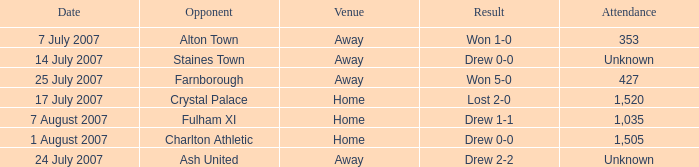Name the venue for staines town Away. 